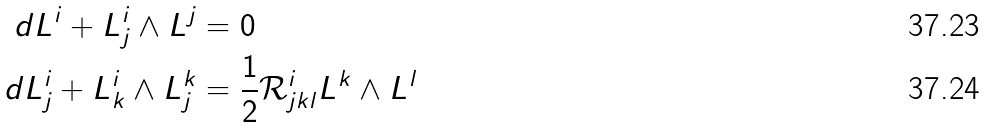Convert formula to latex. <formula><loc_0><loc_0><loc_500><loc_500>d L ^ { i } + L _ { j } ^ { i } \wedge L ^ { j } & = 0 \\ d L _ { j } ^ { i } + L _ { k } ^ { i } \wedge L _ { j } ^ { k } & = \frac { 1 } { 2 } \mathcal { R } _ { j k l } ^ { i } L ^ { k } \wedge L ^ { l }</formula> 